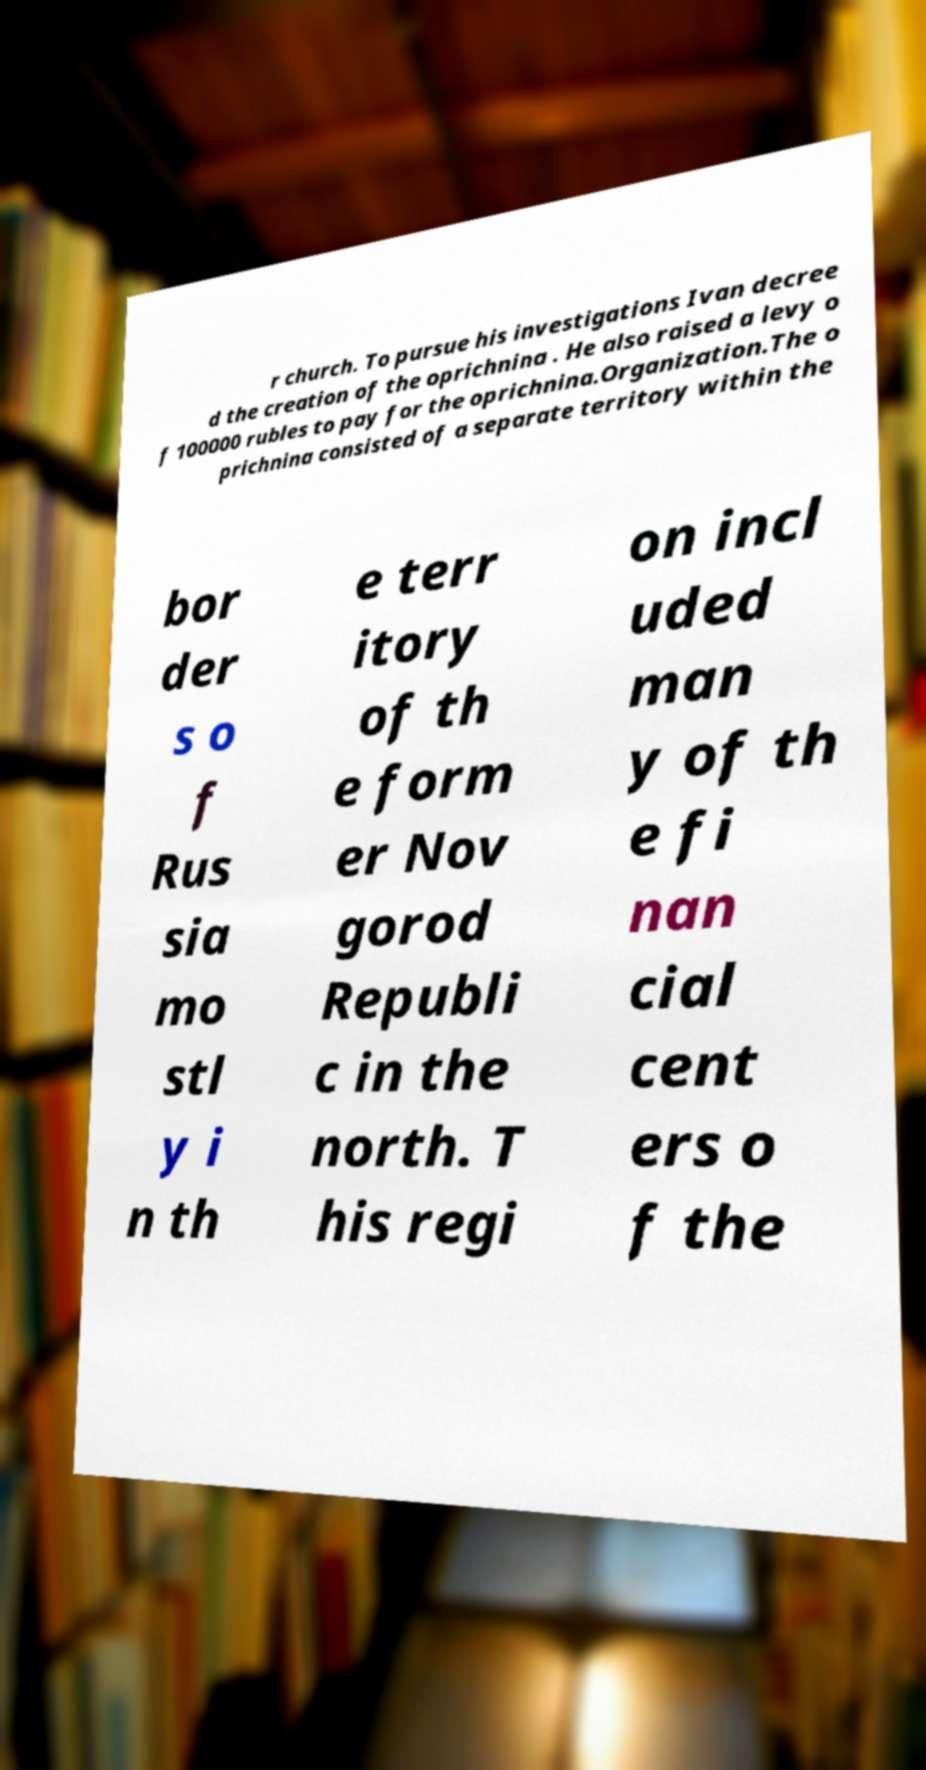For documentation purposes, I need the text within this image transcribed. Could you provide that? r church. To pursue his investigations Ivan decree d the creation of the oprichnina . He also raised a levy o f 100000 rubles to pay for the oprichnina.Organization.The o prichnina consisted of a separate territory within the bor der s o f Rus sia mo stl y i n th e terr itory of th e form er Nov gorod Republi c in the north. T his regi on incl uded man y of th e fi nan cial cent ers o f the 